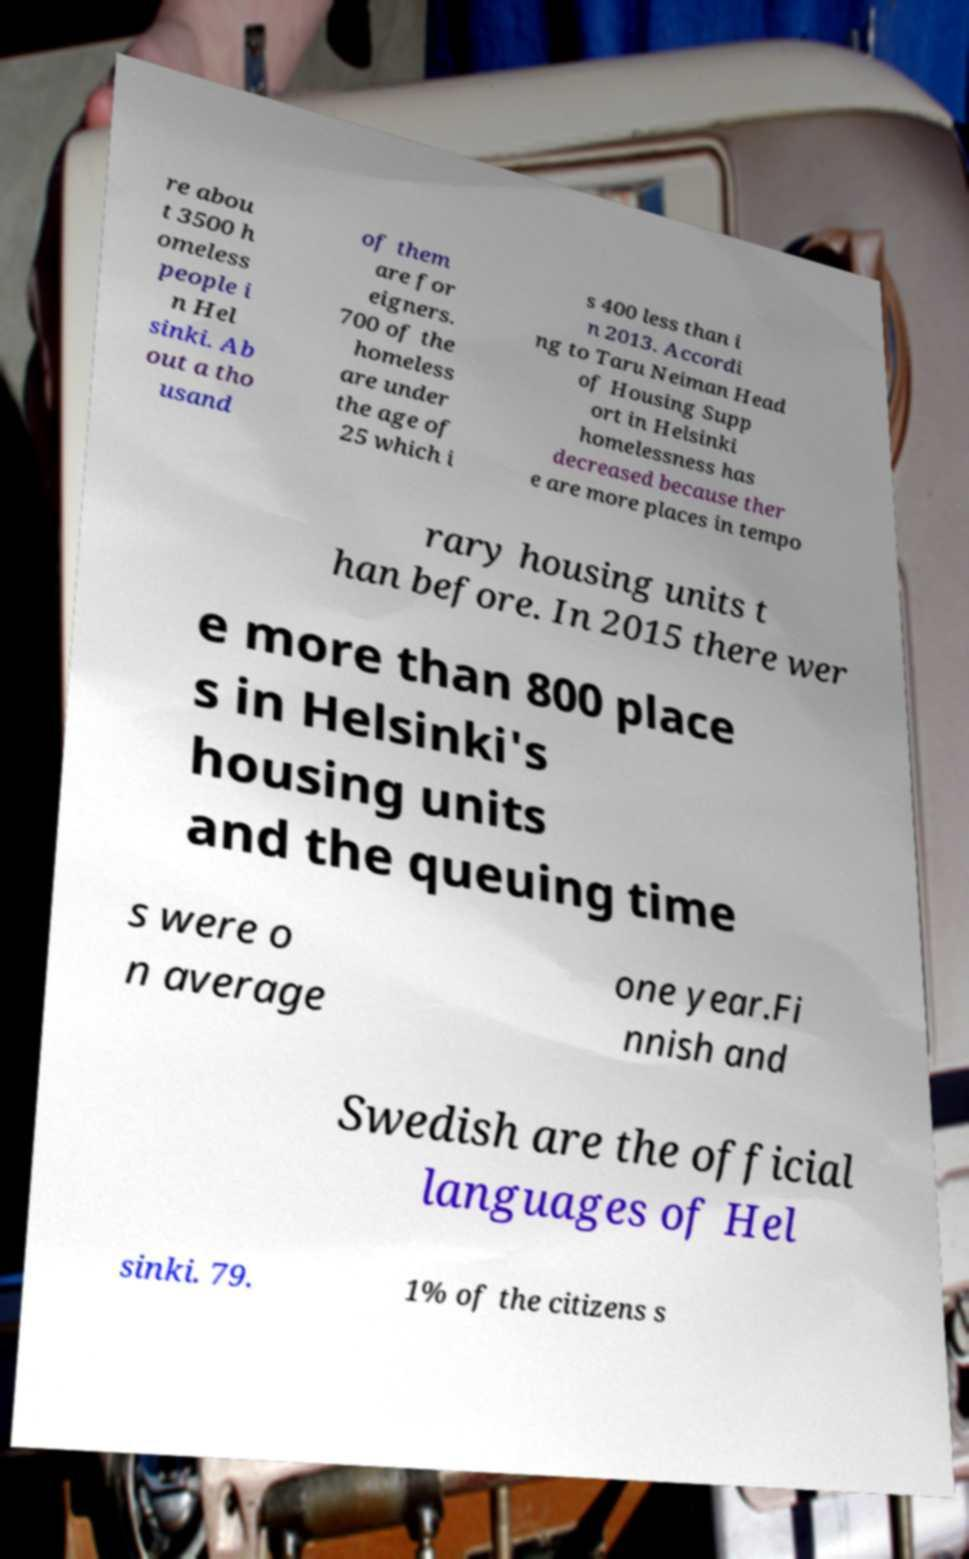Could you extract and type out the text from this image? re abou t 3500 h omeless people i n Hel sinki. Ab out a tho usand of them are for eigners. 700 of the homeless are under the age of 25 which i s 400 less than i n 2013. Accordi ng to Taru Neiman Head of Housing Supp ort in Helsinki homelessness has decreased because ther e are more places in tempo rary housing units t han before. In 2015 there wer e more than 800 place s in Helsinki's housing units and the queuing time s were o n average one year.Fi nnish and Swedish are the official languages of Hel sinki. 79. 1% of the citizens s 